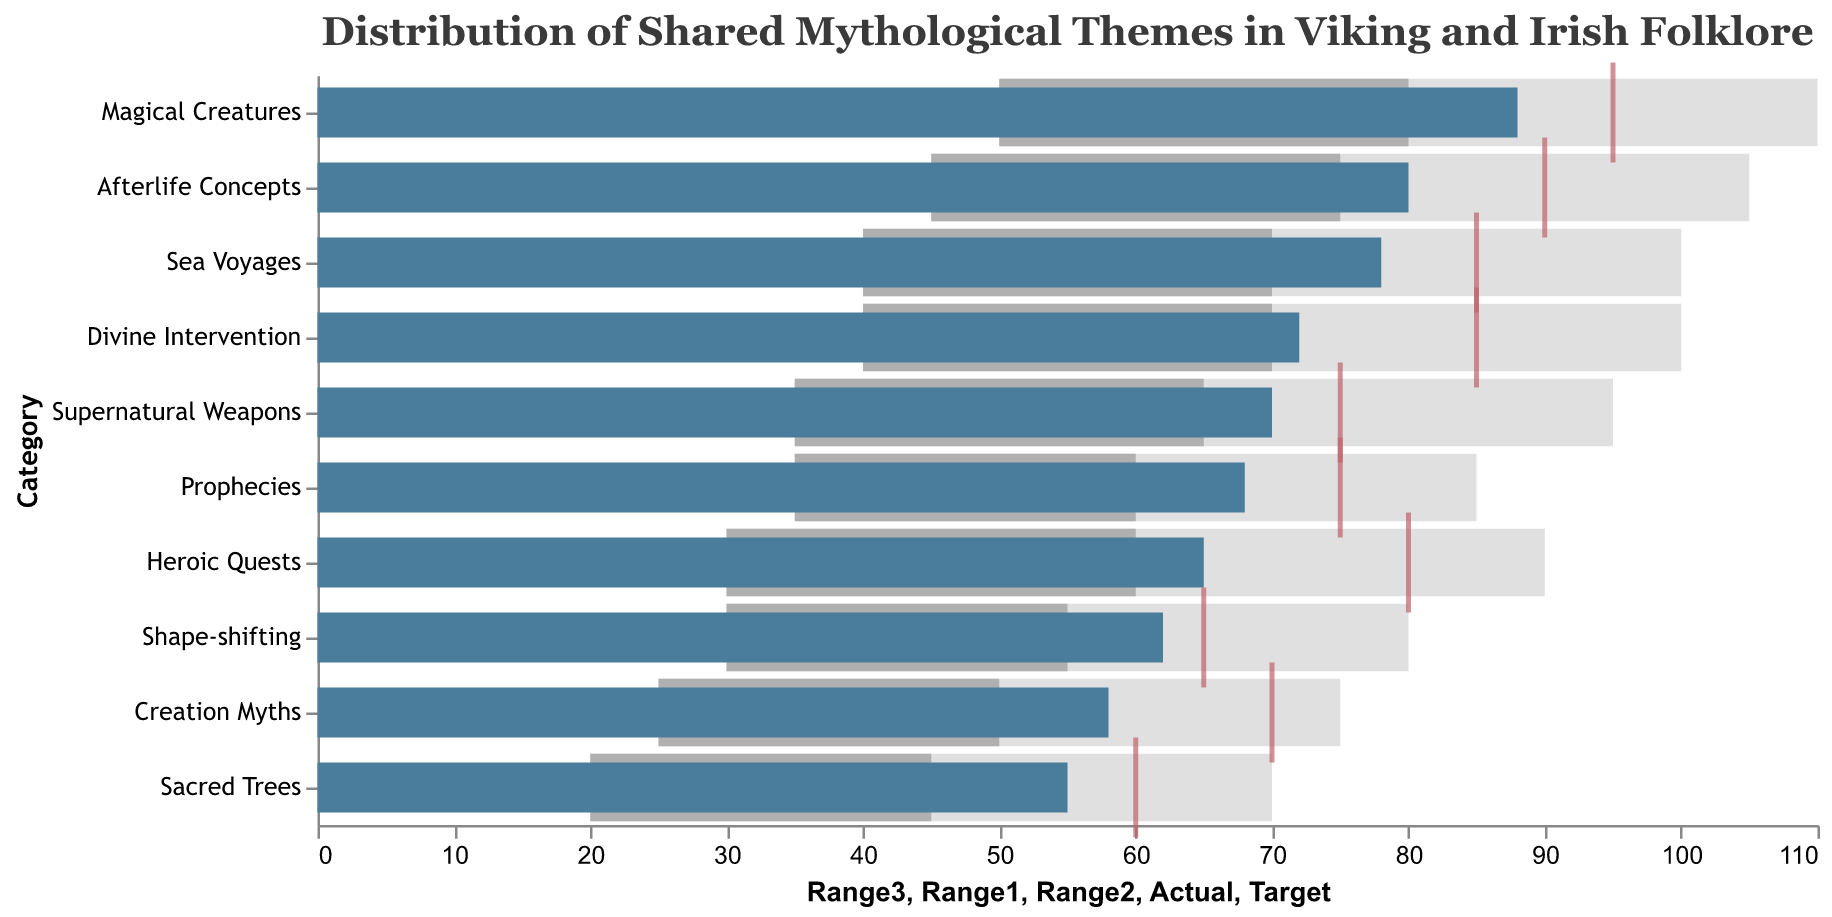What's the title of the plot? The title is displayed at the top of the plot.
Answer: Distribution of Shared Mythological Themes in Viking and Irish Folklore How many categories are analyzed in the plot? Count the number of unique categories on the y-axis.
Answer: 10 Which category has the highest actual value? Identify the highest bar in the plot representing the actual values.
Answer: Magical Creatures For the "Heroic Quests" category, how does the actual value compare to the target value? Compare the bar representing the actual value for "Heroic Quests" with the tick mark representing the target value on the x-axis.
Answer: Actual is lower than Target What is the range of values for the "Sacred Trees" category? Look at the bars representing the different ranges for "Sacred Trees" (Range1 to Range3).
Answer: 20 to 70 Which category has the smallest difference between its actual and target values? Subtract the actual value from the target value for each category and find the smallest difference.
Answer: Shape-shifting How many categories have an actual value of 70 or more? Count the number of categories with bars representing actual values that reach or exceed 70 on the x-axis.
Answer: 7 In which range does the "Afterlife Concepts" category's actual value fall? Observe where the actual value bar for "Afterlife Concepts" falls within the shades representing Range1, Range2, and Range3.
Answer: Range2 Of the categories "Sea Voyages" and "Prophecies," which one has a higher target value? Compare the tick marks representing the target values for "Sea Voyages" and "Prophecies."
Answer: Sea Voyages Is there any category whose actual value exceeds its target value? Check if any bar representing actual value stretches beyond its corresponding tick mark representing the target value.
Answer: No 